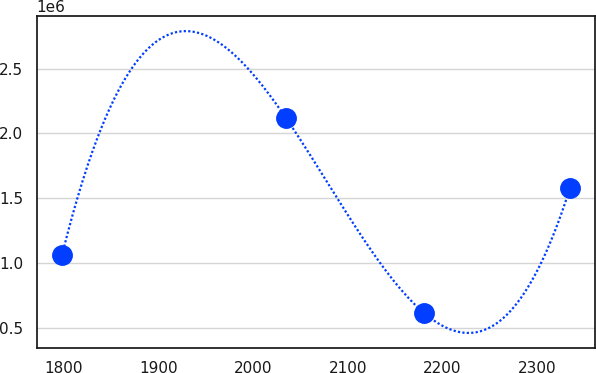Convert chart. <chart><loc_0><loc_0><loc_500><loc_500><line_chart><ecel><fcel>Unnamed: 1<nl><fcel>1797.94<fcel>1.06e+06<nl><fcel>2034.98<fcel>2.11642e+06<nl><fcel>2180.31<fcel>617233<nl><fcel>2334.98<fcel>1.57896e+06<nl></chart> 